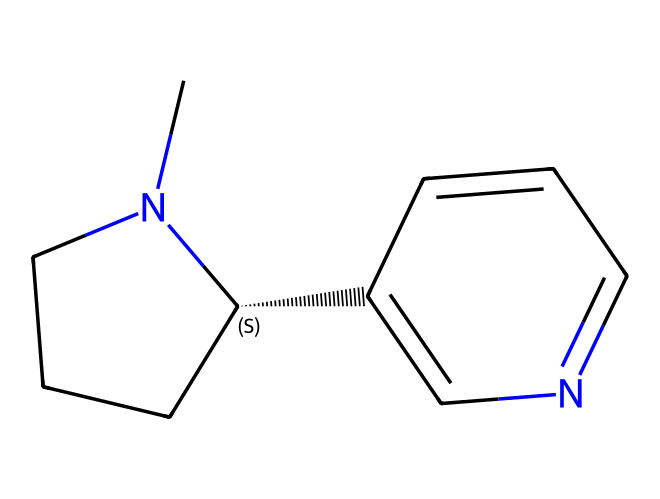What is the major nitrogen-containing functional group in this chemical? The presence of a nitrogen atom in the cyclic structure indicates that the major functional group is a piperidine, which is characteristic of many alkaloids.
Answer: piperidine How many carbon atoms are in the structure? By analyzing the SMILES representation, there are a total of 10 carbon atoms present in the molecular structure.
Answer: 10 What type of chemical is nicotine classified as? Nicotine is specifically classified as an alkaloid due to its nitrogen-rich structure and physiological effects, typical of alkaloids.
Answer: alkaloid What is the stereochemistry of this molecule? The presence of the “@” symbol in the SMILES indicates that there is a chiral center in the molecule, giving it a specific stereochemistry.
Answer: chiral How many rings does the nicotine structure have? Observing the SMILES structure, it can be seen that there are two rings present in the chemical structure of nicotine.
Answer: 2 What physiological effect is most associated with this chemical? Nicotine is known for its stimulating effects on the central nervous system, due to its action as a neurotransmitter and its highly addictive nature.
Answer: stimulating What element is crucial for the interaction with nicotinic receptors? The nitrogen atom in nicotine is crucial for the interaction with nicotinic acetylcholine receptors in the body, influencing its effects.
Answer: nitrogen 